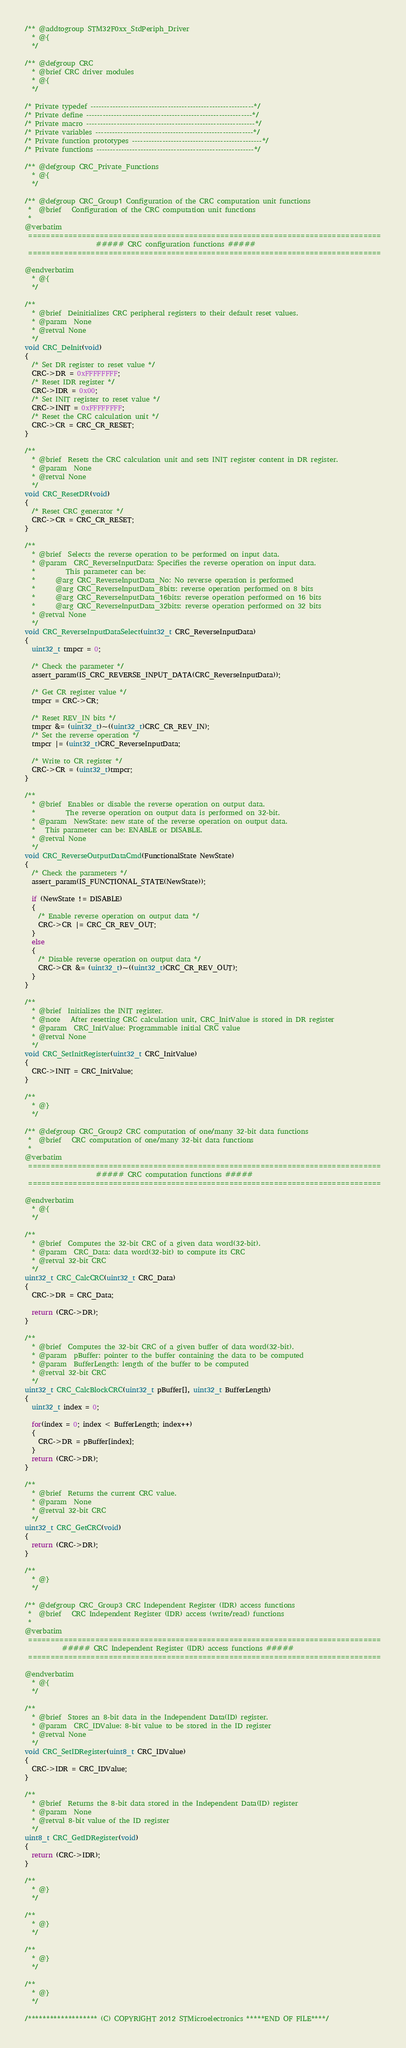Convert code to text. <code><loc_0><loc_0><loc_500><loc_500><_C_>/** @addtogroup STM32F0xx_StdPeriph_Driver
  * @{
  */

/** @defgroup CRC 
  * @brief CRC driver modules
  * @{
  */

/* Private typedef -----------------------------------------------------------*/
/* Private define ------------------------------------------------------------*/
/* Private macro -------------------------------------------------------------*/
/* Private variables ---------------------------------------------------------*/
/* Private function prototypes -----------------------------------------------*/
/* Private functions ---------------------------------------------------------*/

/** @defgroup CRC_Private_Functions
  * @{
  */

/** @defgroup CRC_Group1 Configuration of the CRC computation unit functions
 *  @brief   Configuration of the CRC computation unit functions 
 *
@verbatim
 ===============================================================================
                     ##### CRC configuration functions #####
 ===============================================================================

@endverbatim
  * @{
  */

/**
  * @brief  Deinitializes CRC peripheral registers to their default reset values.
  * @param  None
  * @retval None
  */
void CRC_DeInit(void)
{
  /* Set DR register to reset value */
  CRC->DR = 0xFFFFFFFF;
  /* Reset IDR register */
  CRC->IDR = 0x00;
  /* Set INIT register to reset value */
  CRC->INIT = 0xFFFFFFFF;
  /* Reset the CRC calculation unit */
  CRC->CR = CRC_CR_RESET;
}

/**
  * @brief  Resets the CRC calculation unit and sets INIT register content in DR register.
  * @param  None
  * @retval None
  */
void CRC_ResetDR(void)
{
  /* Reset CRC generator */
  CRC->CR = CRC_CR_RESET;
}

/**
  * @brief  Selects the reverse operation to be performed on input data.
  * @param  CRC_ReverseInputData: Specifies the reverse operation on input data.
  *         This parameter can be:
  *      @arg CRC_ReverseInputData_No: No reverse operation is performed
  *      @arg CRC_ReverseInputData_8bits: reverse operation performed on 8 bits
  *      @arg CRC_ReverseInputData_16bits: reverse operation performed on 16 bits
  *      @arg CRC_ReverseInputData_32bits: reverse operation performed on 32 bits
  * @retval None
  */
void CRC_ReverseInputDataSelect(uint32_t CRC_ReverseInputData)
{
  uint32_t tmpcr = 0;

  /* Check the parameter */
  assert_param(IS_CRC_REVERSE_INPUT_DATA(CRC_ReverseInputData));

  /* Get CR register value */
  tmpcr = CRC->CR;

  /* Reset REV_IN bits */
  tmpcr &= (uint32_t)~((uint32_t)CRC_CR_REV_IN);
  /* Set the reverse operation */
  tmpcr |= (uint32_t)CRC_ReverseInputData;

  /* Write to CR register */
  CRC->CR = (uint32_t)tmpcr;
}

/**
  * @brief  Enables or disable the reverse operation on output data.
  *         The reverse operation on output data is performed on 32-bit.
  * @param  NewState: new state of the reverse operation on output data.
  *   This parameter can be: ENABLE or DISABLE.
  * @retval None
  */
void CRC_ReverseOutputDataCmd(FunctionalState NewState)
{
  /* Check the parameters */
  assert_param(IS_FUNCTIONAL_STATE(NewState));

  if (NewState != DISABLE)
  {
    /* Enable reverse operation on output data */
    CRC->CR |= CRC_CR_REV_OUT;
  }
  else
  {
    /* Disable reverse operation on output data */
    CRC->CR &= (uint32_t)~((uint32_t)CRC_CR_REV_OUT);
  }
}

/**
  * @brief  Initializes the INIT register.
  * @note   After resetting CRC calculation unit, CRC_InitValue is stored in DR register
  * @param  CRC_InitValue: Programmable initial CRC value
  * @retval None
  */
void CRC_SetInitRegister(uint32_t CRC_InitValue)
{
  CRC->INIT = CRC_InitValue;
}

/**
  * @}
  */

/** @defgroup CRC_Group2 CRC computation of one/many 32-bit data functions
 *  @brief   CRC computation of one/many 32-bit data functions
 *
@verbatim
 ===============================================================================
                     ##### CRC computation functions #####
 ===============================================================================

@endverbatim
  * @{
  */

/**
  * @brief  Computes the 32-bit CRC of a given data word(32-bit).
  * @param  CRC_Data: data word(32-bit) to compute its CRC
  * @retval 32-bit CRC
  */
uint32_t CRC_CalcCRC(uint32_t CRC_Data)
{
  CRC->DR = CRC_Data;
  
  return (CRC->DR);
}

/**
  * @brief  Computes the 32-bit CRC of a given buffer of data word(32-bit).
  * @param  pBuffer: pointer to the buffer containing the data to be computed
  * @param  BufferLength: length of the buffer to be computed
  * @retval 32-bit CRC
  */
uint32_t CRC_CalcBlockCRC(uint32_t pBuffer[], uint32_t BufferLength)
{
  uint32_t index = 0;
  
  for(index = 0; index < BufferLength; index++)
  {
    CRC->DR = pBuffer[index];
  }
  return (CRC->DR);
}

/**
  * @brief  Returns the current CRC value.
  * @param  None
  * @retval 32-bit CRC
  */
uint32_t CRC_GetCRC(void)
{
  return (CRC->DR);
}

/**
  * @}
  */

/** @defgroup CRC_Group3 CRC Independent Register (IDR) access functions
 *  @brief   CRC Independent Register (IDR) access (write/read) functions
 *
@verbatim
 ===============================================================================
           ##### CRC Independent Register (IDR) access functions #####
 ===============================================================================

@endverbatim
  * @{
  */

/**
  * @brief  Stores an 8-bit data in the Independent Data(ID) register.
  * @param  CRC_IDValue: 8-bit value to be stored in the ID register 					
  * @retval None
  */
void CRC_SetIDRegister(uint8_t CRC_IDValue)
{
  CRC->IDR = CRC_IDValue;
}

/**
  * @brief  Returns the 8-bit data stored in the Independent Data(ID) register
  * @param  None
  * @retval 8-bit value of the ID register 
  */
uint8_t CRC_GetIDRegister(void)
{
  return (CRC->IDR);
}

/**
  * @}
  */

/**
  * @}
  */

/**
  * @}
  */

/**
  * @}
  */

/******************* (C) COPYRIGHT 2012 STMicroelectronics *****END OF FILE****/
</code> 